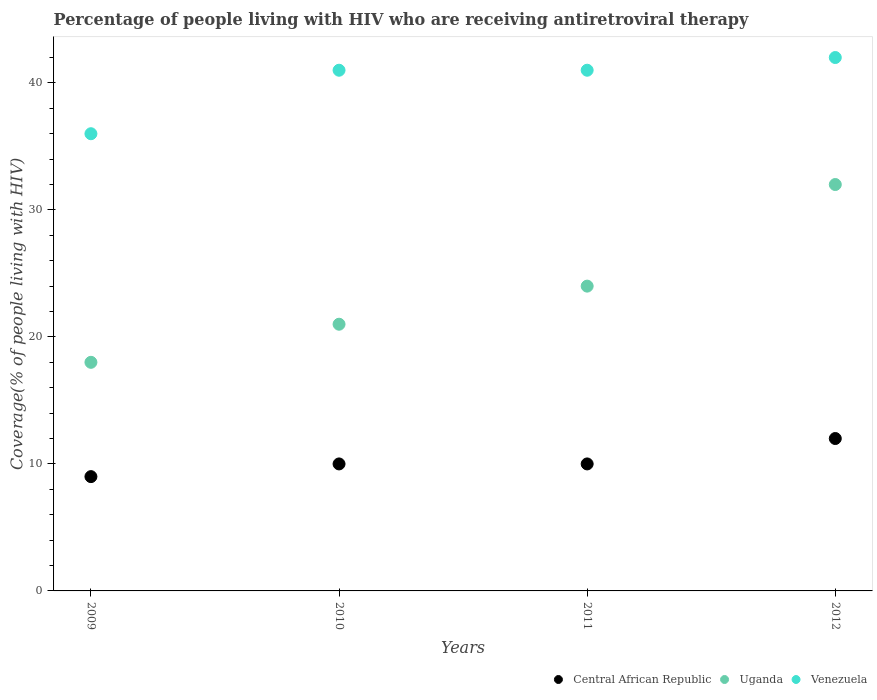What is the percentage of the HIV infected people who are receiving antiretroviral therapy in Uganda in 2012?
Your answer should be compact. 32. Across all years, what is the maximum percentage of the HIV infected people who are receiving antiretroviral therapy in Central African Republic?
Offer a very short reply. 12. Across all years, what is the minimum percentage of the HIV infected people who are receiving antiretroviral therapy in Venezuela?
Your answer should be compact. 36. In which year was the percentage of the HIV infected people who are receiving antiretroviral therapy in Venezuela minimum?
Offer a very short reply. 2009. What is the total percentage of the HIV infected people who are receiving antiretroviral therapy in Uganda in the graph?
Keep it short and to the point. 95. What is the difference between the percentage of the HIV infected people who are receiving antiretroviral therapy in Central African Republic in 2010 and that in 2012?
Ensure brevity in your answer.  -2. What is the difference between the percentage of the HIV infected people who are receiving antiretroviral therapy in Venezuela in 2009 and the percentage of the HIV infected people who are receiving antiretroviral therapy in Uganda in 2010?
Your answer should be compact. 15. In the year 2010, what is the difference between the percentage of the HIV infected people who are receiving antiretroviral therapy in Venezuela and percentage of the HIV infected people who are receiving antiretroviral therapy in Uganda?
Offer a terse response. 20. In how many years, is the percentage of the HIV infected people who are receiving antiretroviral therapy in Central African Republic greater than 28 %?
Make the answer very short. 0. Is the difference between the percentage of the HIV infected people who are receiving antiretroviral therapy in Venezuela in 2010 and 2012 greater than the difference between the percentage of the HIV infected people who are receiving antiretroviral therapy in Uganda in 2010 and 2012?
Offer a very short reply. Yes. What is the difference between the highest and the lowest percentage of the HIV infected people who are receiving antiretroviral therapy in Central African Republic?
Make the answer very short. 3. Is the sum of the percentage of the HIV infected people who are receiving antiretroviral therapy in Uganda in 2011 and 2012 greater than the maximum percentage of the HIV infected people who are receiving antiretroviral therapy in Venezuela across all years?
Your answer should be very brief. Yes. Is it the case that in every year, the sum of the percentage of the HIV infected people who are receiving antiretroviral therapy in Uganda and percentage of the HIV infected people who are receiving antiretroviral therapy in Venezuela  is greater than the percentage of the HIV infected people who are receiving antiretroviral therapy in Central African Republic?
Give a very brief answer. Yes. Is the percentage of the HIV infected people who are receiving antiretroviral therapy in Central African Republic strictly greater than the percentage of the HIV infected people who are receiving antiretroviral therapy in Venezuela over the years?
Keep it short and to the point. No. Is the percentage of the HIV infected people who are receiving antiretroviral therapy in Venezuela strictly less than the percentage of the HIV infected people who are receiving antiretroviral therapy in Central African Republic over the years?
Your answer should be compact. No. How many dotlines are there?
Give a very brief answer. 3. How many years are there in the graph?
Provide a short and direct response. 4. Does the graph contain any zero values?
Ensure brevity in your answer.  No. Does the graph contain grids?
Your answer should be very brief. No. What is the title of the graph?
Offer a very short reply. Percentage of people living with HIV who are receiving antiretroviral therapy. What is the label or title of the X-axis?
Your response must be concise. Years. What is the label or title of the Y-axis?
Provide a succinct answer. Coverage(% of people living with HIV). What is the Coverage(% of people living with HIV) in Central African Republic in 2009?
Your answer should be very brief. 9. What is the Coverage(% of people living with HIV) in Uganda in 2009?
Your answer should be very brief. 18. What is the Coverage(% of people living with HIV) of Venezuela in 2009?
Make the answer very short. 36. What is the Coverage(% of people living with HIV) in Uganda in 2010?
Ensure brevity in your answer.  21. What is the Coverage(% of people living with HIV) of Central African Republic in 2011?
Provide a succinct answer. 10. What is the Coverage(% of people living with HIV) in Uganda in 2011?
Make the answer very short. 24. What is the Coverage(% of people living with HIV) of Venezuela in 2011?
Make the answer very short. 41. What is the Coverage(% of people living with HIV) of Central African Republic in 2012?
Your response must be concise. 12. Across all years, what is the maximum Coverage(% of people living with HIV) of Uganda?
Keep it short and to the point. 32. Across all years, what is the maximum Coverage(% of people living with HIV) in Venezuela?
Your response must be concise. 42. Across all years, what is the minimum Coverage(% of people living with HIV) of Central African Republic?
Your answer should be compact. 9. Across all years, what is the minimum Coverage(% of people living with HIV) in Venezuela?
Offer a very short reply. 36. What is the total Coverage(% of people living with HIV) of Central African Republic in the graph?
Your answer should be very brief. 41. What is the total Coverage(% of people living with HIV) of Venezuela in the graph?
Ensure brevity in your answer.  160. What is the difference between the Coverage(% of people living with HIV) in Central African Republic in 2009 and that in 2011?
Your answer should be very brief. -1. What is the difference between the Coverage(% of people living with HIV) of Venezuela in 2009 and that in 2011?
Ensure brevity in your answer.  -5. What is the difference between the Coverage(% of people living with HIV) of Venezuela in 2009 and that in 2012?
Provide a short and direct response. -6. What is the difference between the Coverage(% of people living with HIV) in Central African Republic in 2010 and that in 2011?
Your response must be concise. 0. What is the difference between the Coverage(% of people living with HIV) in Uganda in 2010 and that in 2011?
Your answer should be very brief. -3. What is the difference between the Coverage(% of people living with HIV) in Venezuela in 2010 and that in 2011?
Give a very brief answer. 0. What is the difference between the Coverage(% of people living with HIV) of Uganda in 2010 and that in 2012?
Provide a short and direct response. -11. What is the difference between the Coverage(% of people living with HIV) of Central African Republic in 2011 and that in 2012?
Your answer should be very brief. -2. What is the difference between the Coverage(% of people living with HIV) of Uganda in 2011 and that in 2012?
Make the answer very short. -8. What is the difference between the Coverage(% of people living with HIV) of Central African Republic in 2009 and the Coverage(% of people living with HIV) of Uganda in 2010?
Your answer should be compact. -12. What is the difference between the Coverage(% of people living with HIV) in Central African Republic in 2009 and the Coverage(% of people living with HIV) in Venezuela in 2010?
Ensure brevity in your answer.  -32. What is the difference between the Coverage(% of people living with HIV) in Central African Republic in 2009 and the Coverage(% of people living with HIV) in Uganda in 2011?
Your answer should be very brief. -15. What is the difference between the Coverage(% of people living with HIV) of Central African Republic in 2009 and the Coverage(% of people living with HIV) of Venezuela in 2011?
Make the answer very short. -32. What is the difference between the Coverage(% of people living with HIV) in Uganda in 2009 and the Coverage(% of people living with HIV) in Venezuela in 2011?
Offer a terse response. -23. What is the difference between the Coverage(% of people living with HIV) in Central African Republic in 2009 and the Coverage(% of people living with HIV) in Venezuela in 2012?
Your response must be concise. -33. What is the difference between the Coverage(% of people living with HIV) of Central African Republic in 2010 and the Coverage(% of people living with HIV) of Venezuela in 2011?
Offer a terse response. -31. What is the difference between the Coverage(% of people living with HIV) of Central African Republic in 2010 and the Coverage(% of people living with HIV) of Venezuela in 2012?
Ensure brevity in your answer.  -32. What is the difference between the Coverage(% of people living with HIV) of Uganda in 2010 and the Coverage(% of people living with HIV) of Venezuela in 2012?
Offer a very short reply. -21. What is the difference between the Coverage(% of people living with HIV) in Central African Republic in 2011 and the Coverage(% of people living with HIV) in Uganda in 2012?
Give a very brief answer. -22. What is the difference between the Coverage(% of people living with HIV) of Central African Republic in 2011 and the Coverage(% of people living with HIV) of Venezuela in 2012?
Give a very brief answer. -32. What is the average Coverage(% of people living with HIV) in Central African Republic per year?
Give a very brief answer. 10.25. What is the average Coverage(% of people living with HIV) in Uganda per year?
Your answer should be very brief. 23.75. What is the average Coverage(% of people living with HIV) in Venezuela per year?
Offer a terse response. 40. In the year 2009, what is the difference between the Coverage(% of people living with HIV) in Uganda and Coverage(% of people living with HIV) in Venezuela?
Your answer should be very brief. -18. In the year 2010, what is the difference between the Coverage(% of people living with HIV) in Central African Republic and Coverage(% of people living with HIV) in Uganda?
Keep it short and to the point. -11. In the year 2010, what is the difference between the Coverage(% of people living with HIV) in Central African Republic and Coverage(% of people living with HIV) in Venezuela?
Provide a short and direct response. -31. In the year 2011, what is the difference between the Coverage(% of people living with HIV) in Central African Republic and Coverage(% of people living with HIV) in Uganda?
Provide a short and direct response. -14. In the year 2011, what is the difference between the Coverage(% of people living with HIV) of Central African Republic and Coverage(% of people living with HIV) of Venezuela?
Provide a short and direct response. -31. In the year 2011, what is the difference between the Coverage(% of people living with HIV) of Uganda and Coverage(% of people living with HIV) of Venezuela?
Ensure brevity in your answer.  -17. In the year 2012, what is the difference between the Coverage(% of people living with HIV) of Central African Republic and Coverage(% of people living with HIV) of Uganda?
Your answer should be compact. -20. In the year 2012, what is the difference between the Coverage(% of people living with HIV) in Uganda and Coverage(% of people living with HIV) in Venezuela?
Ensure brevity in your answer.  -10. What is the ratio of the Coverage(% of people living with HIV) in Central African Republic in 2009 to that in 2010?
Provide a short and direct response. 0.9. What is the ratio of the Coverage(% of people living with HIV) in Uganda in 2009 to that in 2010?
Make the answer very short. 0.86. What is the ratio of the Coverage(% of people living with HIV) in Venezuela in 2009 to that in 2010?
Provide a succinct answer. 0.88. What is the ratio of the Coverage(% of people living with HIV) of Central African Republic in 2009 to that in 2011?
Your answer should be very brief. 0.9. What is the ratio of the Coverage(% of people living with HIV) of Venezuela in 2009 to that in 2011?
Provide a succinct answer. 0.88. What is the ratio of the Coverage(% of people living with HIV) of Uganda in 2009 to that in 2012?
Your answer should be very brief. 0.56. What is the ratio of the Coverage(% of people living with HIV) of Venezuela in 2009 to that in 2012?
Your answer should be very brief. 0.86. What is the ratio of the Coverage(% of people living with HIV) in Venezuela in 2010 to that in 2011?
Offer a very short reply. 1. What is the ratio of the Coverage(% of people living with HIV) of Central African Republic in 2010 to that in 2012?
Your response must be concise. 0.83. What is the ratio of the Coverage(% of people living with HIV) in Uganda in 2010 to that in 2012?
Make the answer very short. 0.66. What is the ratio of the Coverage(% of people living with HIV) in Venezuela in 2010 to that in 2012?
Make the answer very short. 0.98. What is the ratio of the Coverage(% of people living with HIV) of Uganda in 2011 to that in 2012?
Give a very brief answer. 0.75. What is the ratio of the Coverage(% of people living with HIV) of Venezuela in 2011 to that in 2012?
Offer a terse response. 0.98. What is the difference between the highest and the second highest Coverage(% of people living with HIV) of Uganda?
Offer a very short reply. 8. What is the difference between the highest and the lowest Coverage(% of people living with HIV) of Central African Republic?
Provide a short and direct response. 3. What is the difference between the highest and the lowest Coverage(% of people living with HIV) in Venezuela?
Give a very brief answer. 6. 